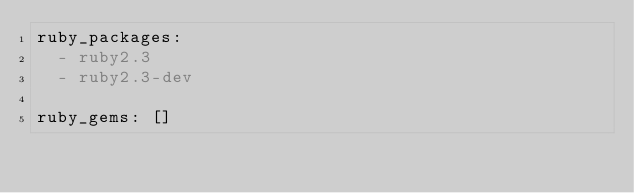<code> <loc_0><loc_0><loc_500><loc_500><_YAML_>ruby_packages:
  - ruby2.3
  - ruby2.3-dev

ruby_gems: []
</code> 